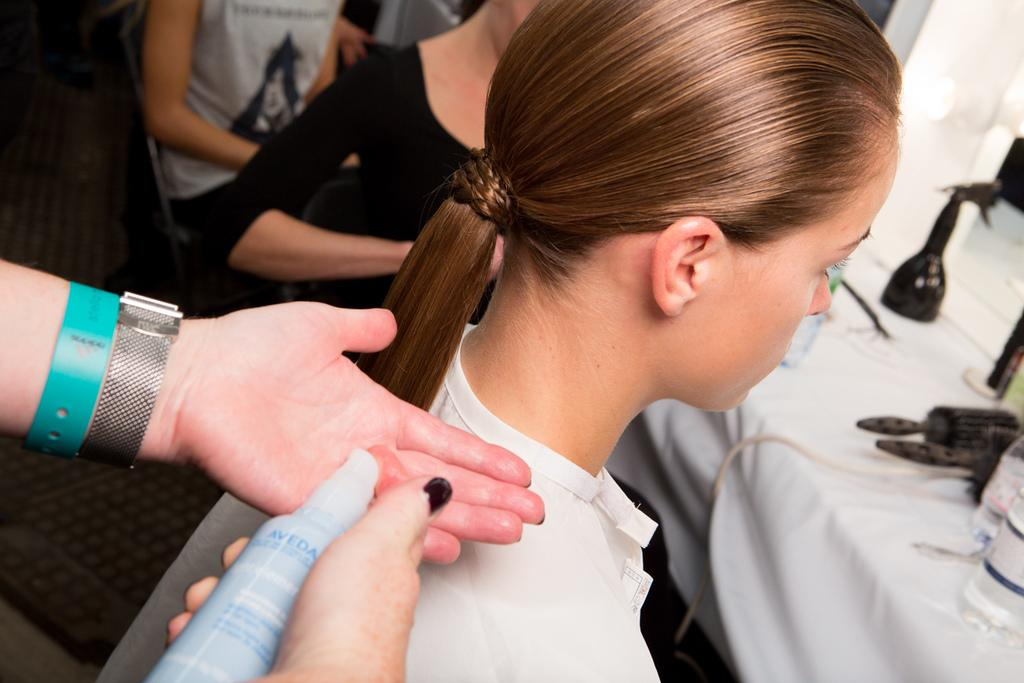What are the people in the image doing? The persons in the image are sitting on chairs. What is in front of the chairs? There is a table in front of the chairs. What is covering the table? There is a tablecloth on the table. What items can be seen on the table? There are plastic bottles and grooming kits on the table. What type of pickle is being served in the kettle on the table? There is no pickle or kettle present in the image; the table only contains plastic bottles and grooming kits. 